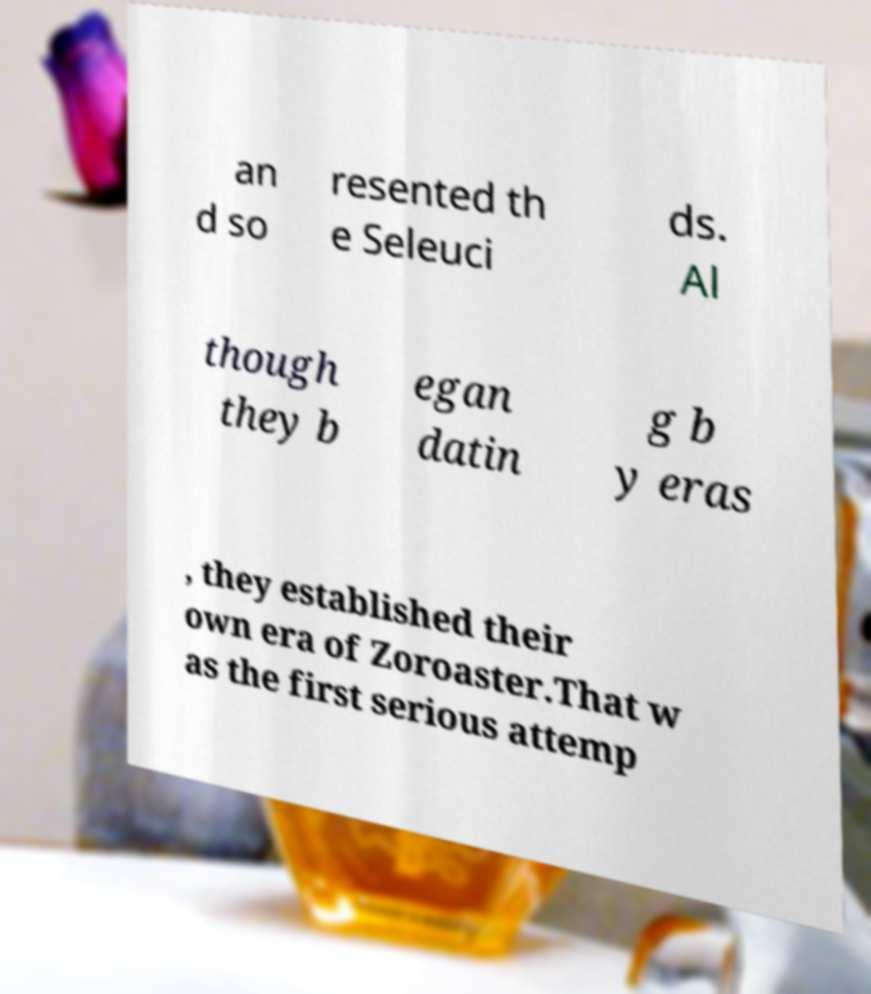For documentation purposes, I need the text within this image transcribed. Could you provide that? an d so resented th e Seleuci ds. Al though they b egan datin g b y eras , they established their own era of Zoroaster.That w as the first serious attemp 